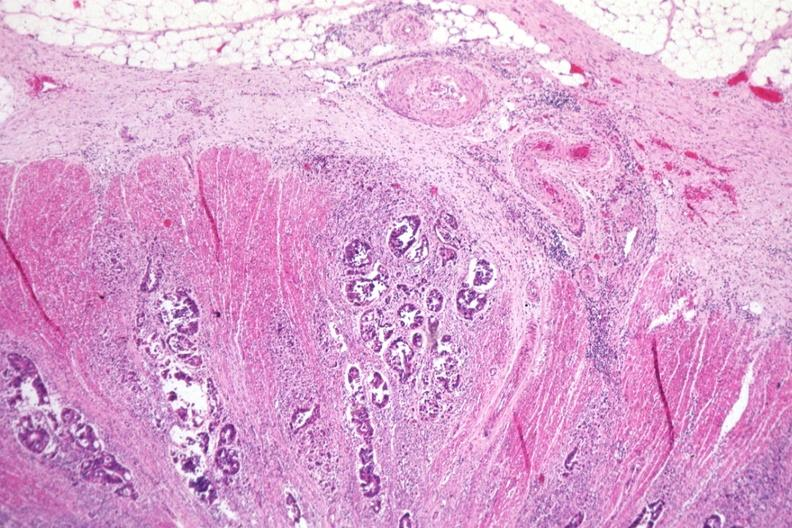what does this image show?
Answer the question using a single word or phrase. Excellent photo typical adenocarcinoma extending through muscularis to serosa 